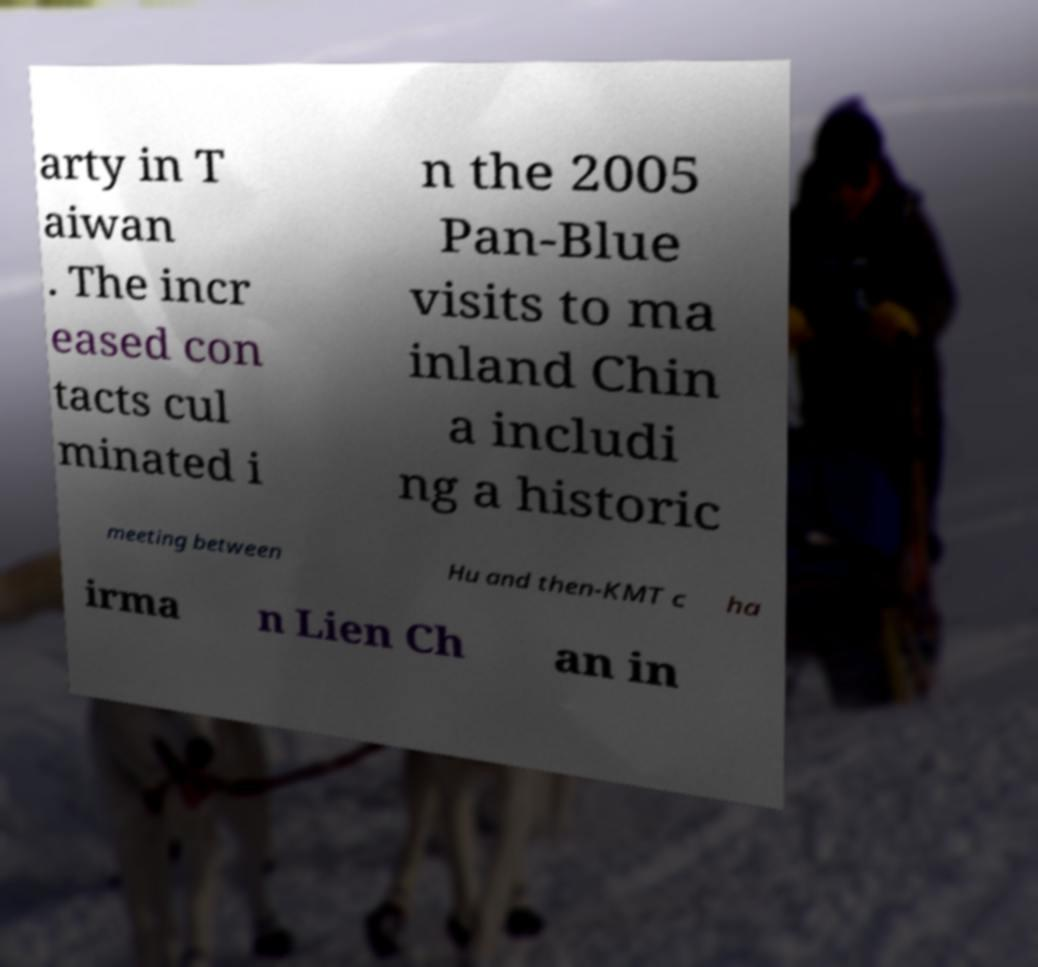What messages or text are displayed in this image? I need them in a readable, typed format. arty in T aiwan . The incr eased con tacts cul minated i n the 2005 Pan-Blue visits to ma inland Chin a includi ng a historic meeting between Hu and then-KMT c ha irma n Lien Ch an in 